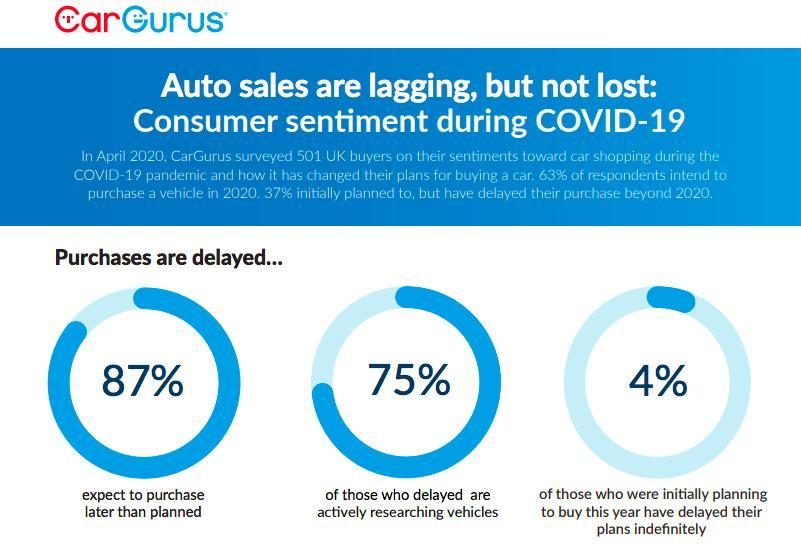What percent of consumers have delayed their plan indefinitely?
Answer the question with a short phrase. 4% What percent of consumers who had delayed are now researching vehicles? 75% What percent of consumers expect to buy a vehicle later than they had planned? 87% 